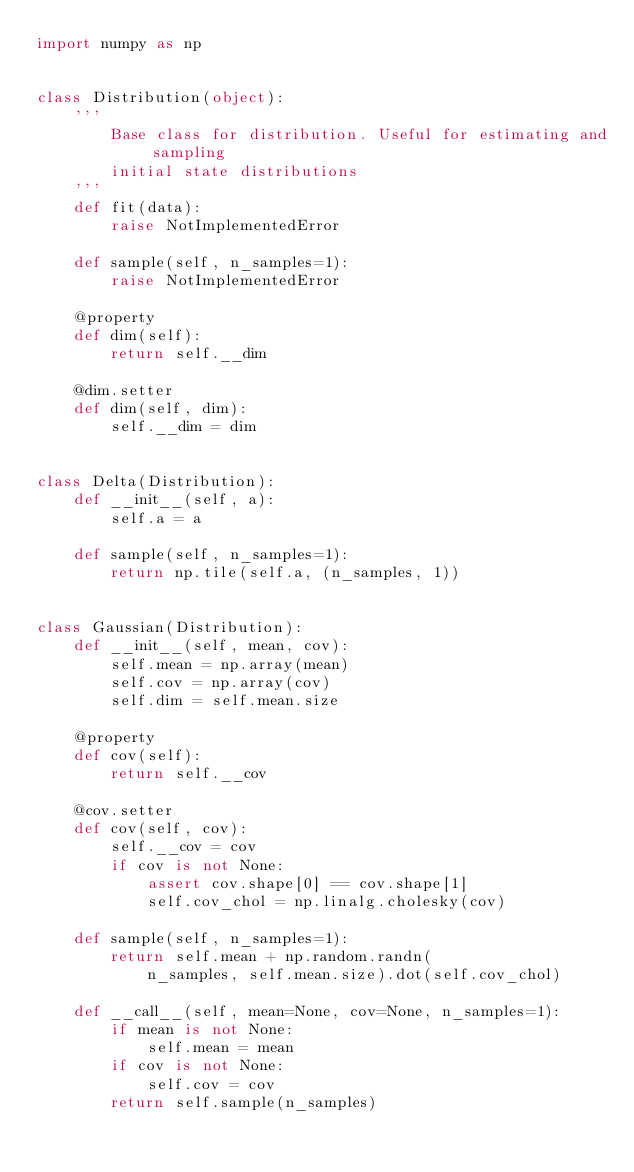<code> <loc_0><loc_0><loc_500><loc_500><_Python_>import numpy as np


class Distribution(object):
    '''
        Base class for distribution. Useful for estimating and sampling
        initial state distributions
    '''
    def fit(data):
        raise NotImplementedError

    def sample(self, n_samples=1):
        raise NotImplementedError

    @property
    def dim(self):
        return self.__dim

    @dim.setter
    def dim(self, dim):
        self.__dim = dim


class Delta(Distribution):
    def __init__(self, a):
        self.a = a

    def sample(self, n_samples=1):
        return np.tile(self.a, (n_samples, 1))


class Gaussian(Distribution):
    def __init__(self, mean, cov):
        self.mean = np.array(mean)
        self.cov = np.array(cov)
        self.dim = self.mean.size

    @property
    def cov(self):
        return self.__cov

    @cov.setter
    def cov(self, cov):
        self.__cov = cov
        if cov is not None:
            assert cov.shape[0] == cov.shape[1]
            self.cov_chol = np.linalg.cholesky(cov)

    def sample(self, n_samples=1):
        return self.mean + np.random.randn(
            n_samples, self.mean.size).dot(self.cov_chol)

    def __call__(self, mean=None, cov=None, n_samples=1):
        if mean is not None:
            self.mean = mean
        if cov is not None:
            self.cov = cov
        return self.sample(n_samples)
</code> 